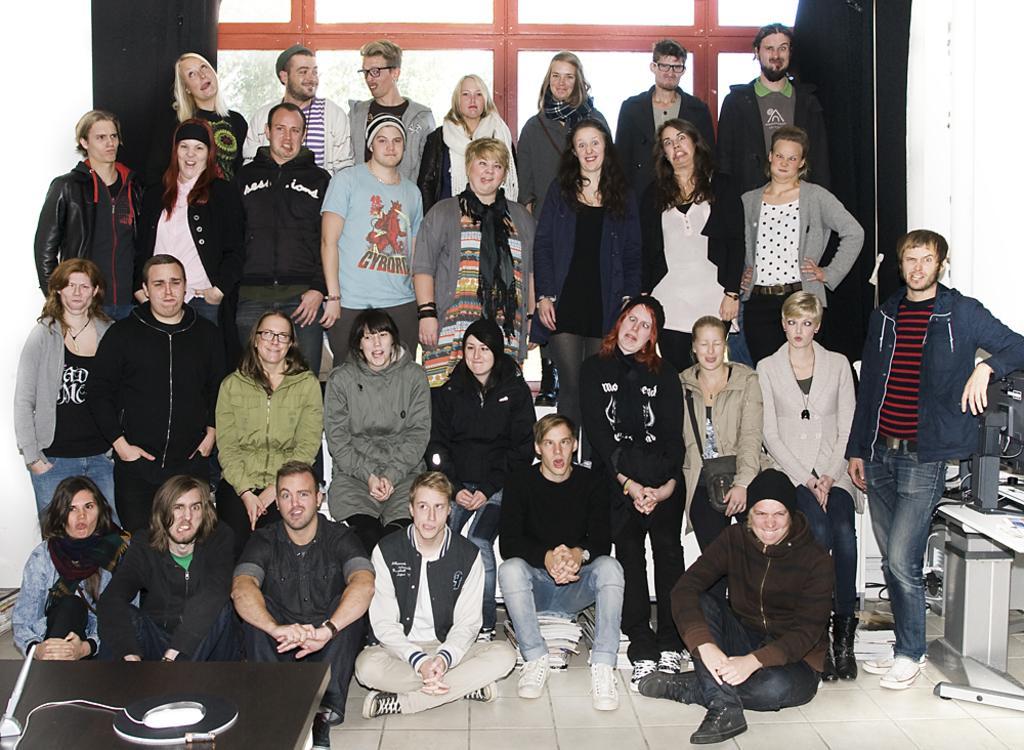In one or two sentences, can you explain what this image depicts? In the image I can see the group of people are wearing different color dresses. I can see few objects on the tables. Back I can see trees and the window. 